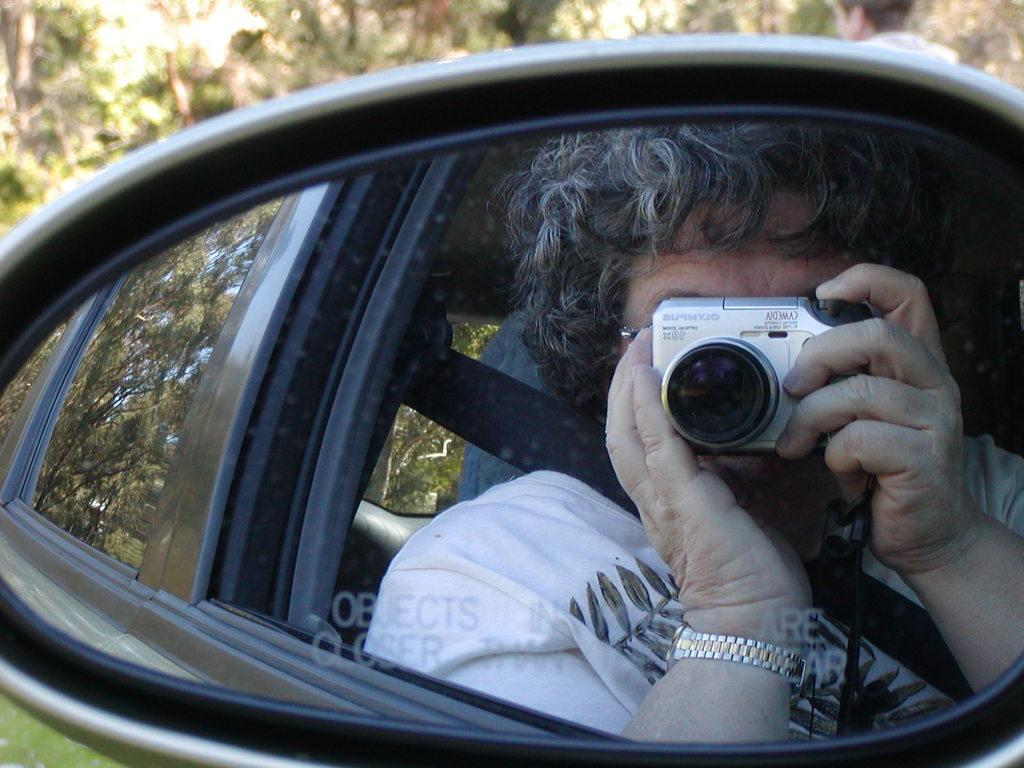What is the main subject of the image? The main subject of the image is a car. What is the person in the image doing? The person is holding a camera. What type of natural environment is visible in the image? There are trees in the image. What type of box is being used to store the person's ideas in the image? There is no box or reference to storing ideas in the image; it features a car and a person holding a camera. 